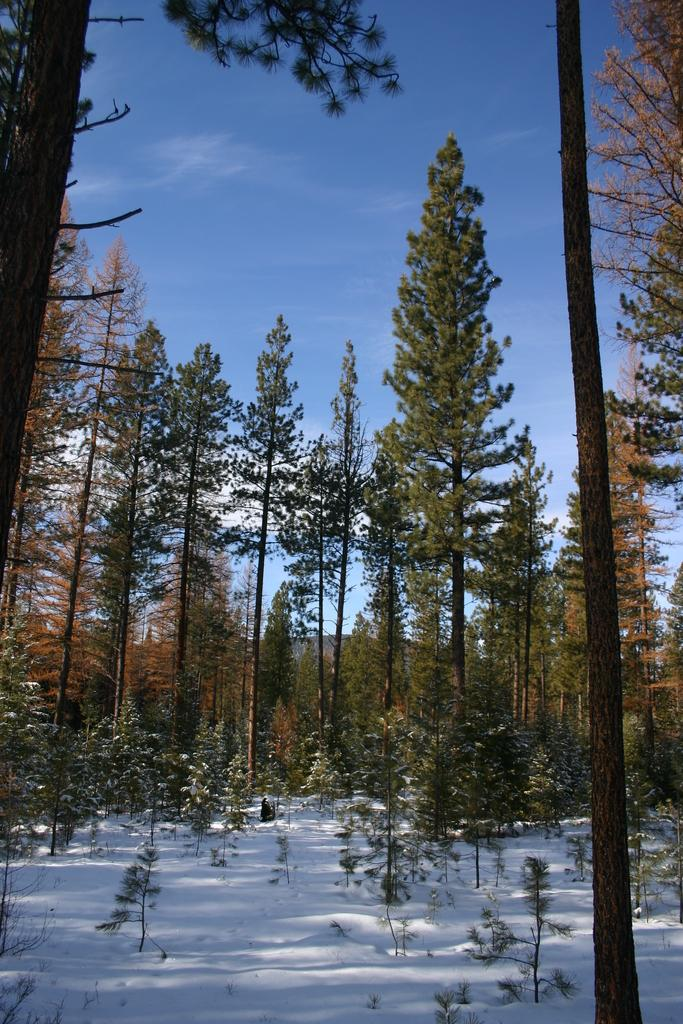What type of vegetation is present in the image? There are many trees in the image. What geographical feature can be seen in the background? There is a mountain visible in the background. What is visible at the top of the image? The sky is visible at the top of the image. What can be observed in the sky? Clouds are present in the sky. What type of weather condition might be suggested by the presence of snow at the bottom of the image? The presence of snow at the bottom of the image suggests a cold weather condition. What type of locket can be seen hanging from the tree in the image? There is no locket present in the image; it features trees, a mountain, clouds, and snow. What season is depicted in the image, considering the presence of summer clothing? The image does not depict any clothing, so it cannot be determined if it is summer or any other season. 